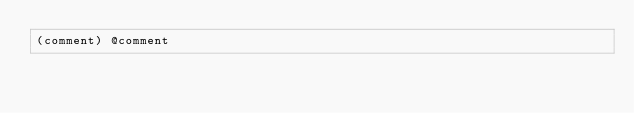Convert code to text. <code><loc_0><loc_0><loc_500><loc_500><_Scheme_>(comment) @comment
</code> 